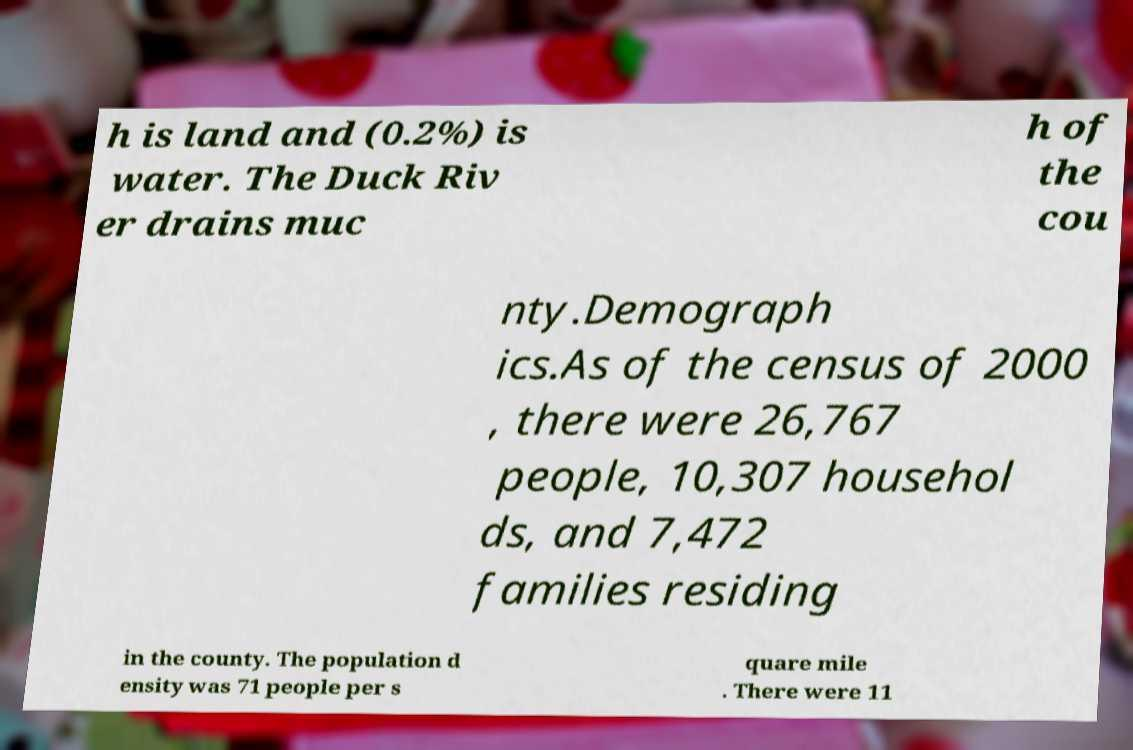Can you read and provide the text displayed in the image?This photo seems to have some interesting text. Can you extract and type it out for me? h is land and (0.2%) is water. The Duck Riv er drains muc h of the cou nty.Demograph ics.As of the census of 2000 , there were 26,767 people, 10,307 househol ds, and 7,472 families residing in the county. The population d ensity was 71 people per s quare mile . There were 11 